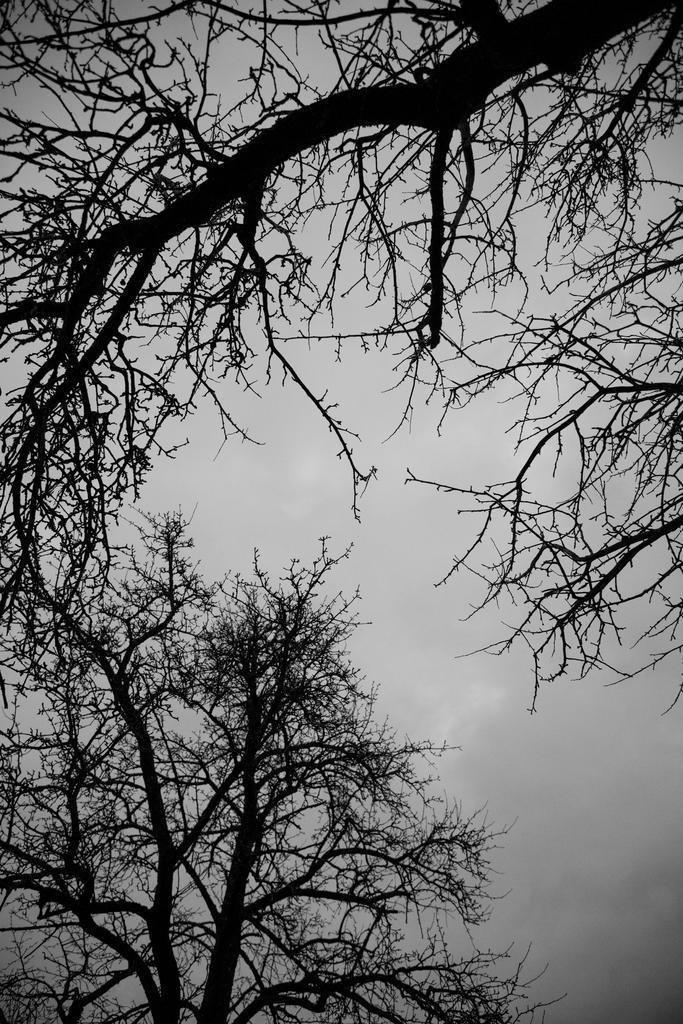What type of vegetation can be seen in the image? There are trees in the image. What part of the natural environment is visible in the image? The sky is visible in the background of the image. How many crates are stacked next to the trees in the image? There are no crates present in the image. What type of animals can be seen interacting with the trees in the image? There are no animals, including mice, present in the image. 